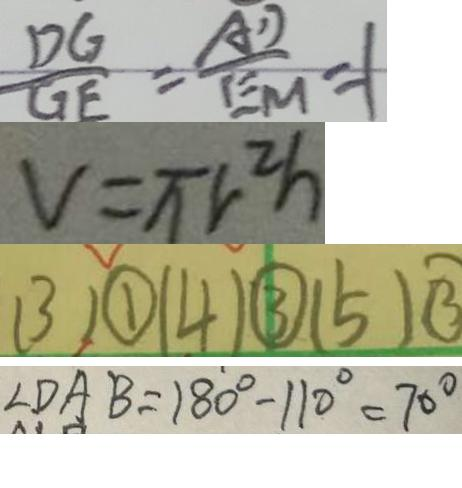<formula> <loc_0><loc_0><loc_500><loc_500>\frac { D G } { G E } = \frac { A D } { E M } = 1 
 V = \pi r ^ { 2 } h 
 ( 3 ) \textcircled { 1 } ( 4 ) \textcircled { 3 } ( 5 ) \textcircled { 3 } 
 \angle D A B = 1 8 0 ^ { \circ } - 1 1 0 ^ { \circ } = 7 0 ^ { \circ }</formula> 